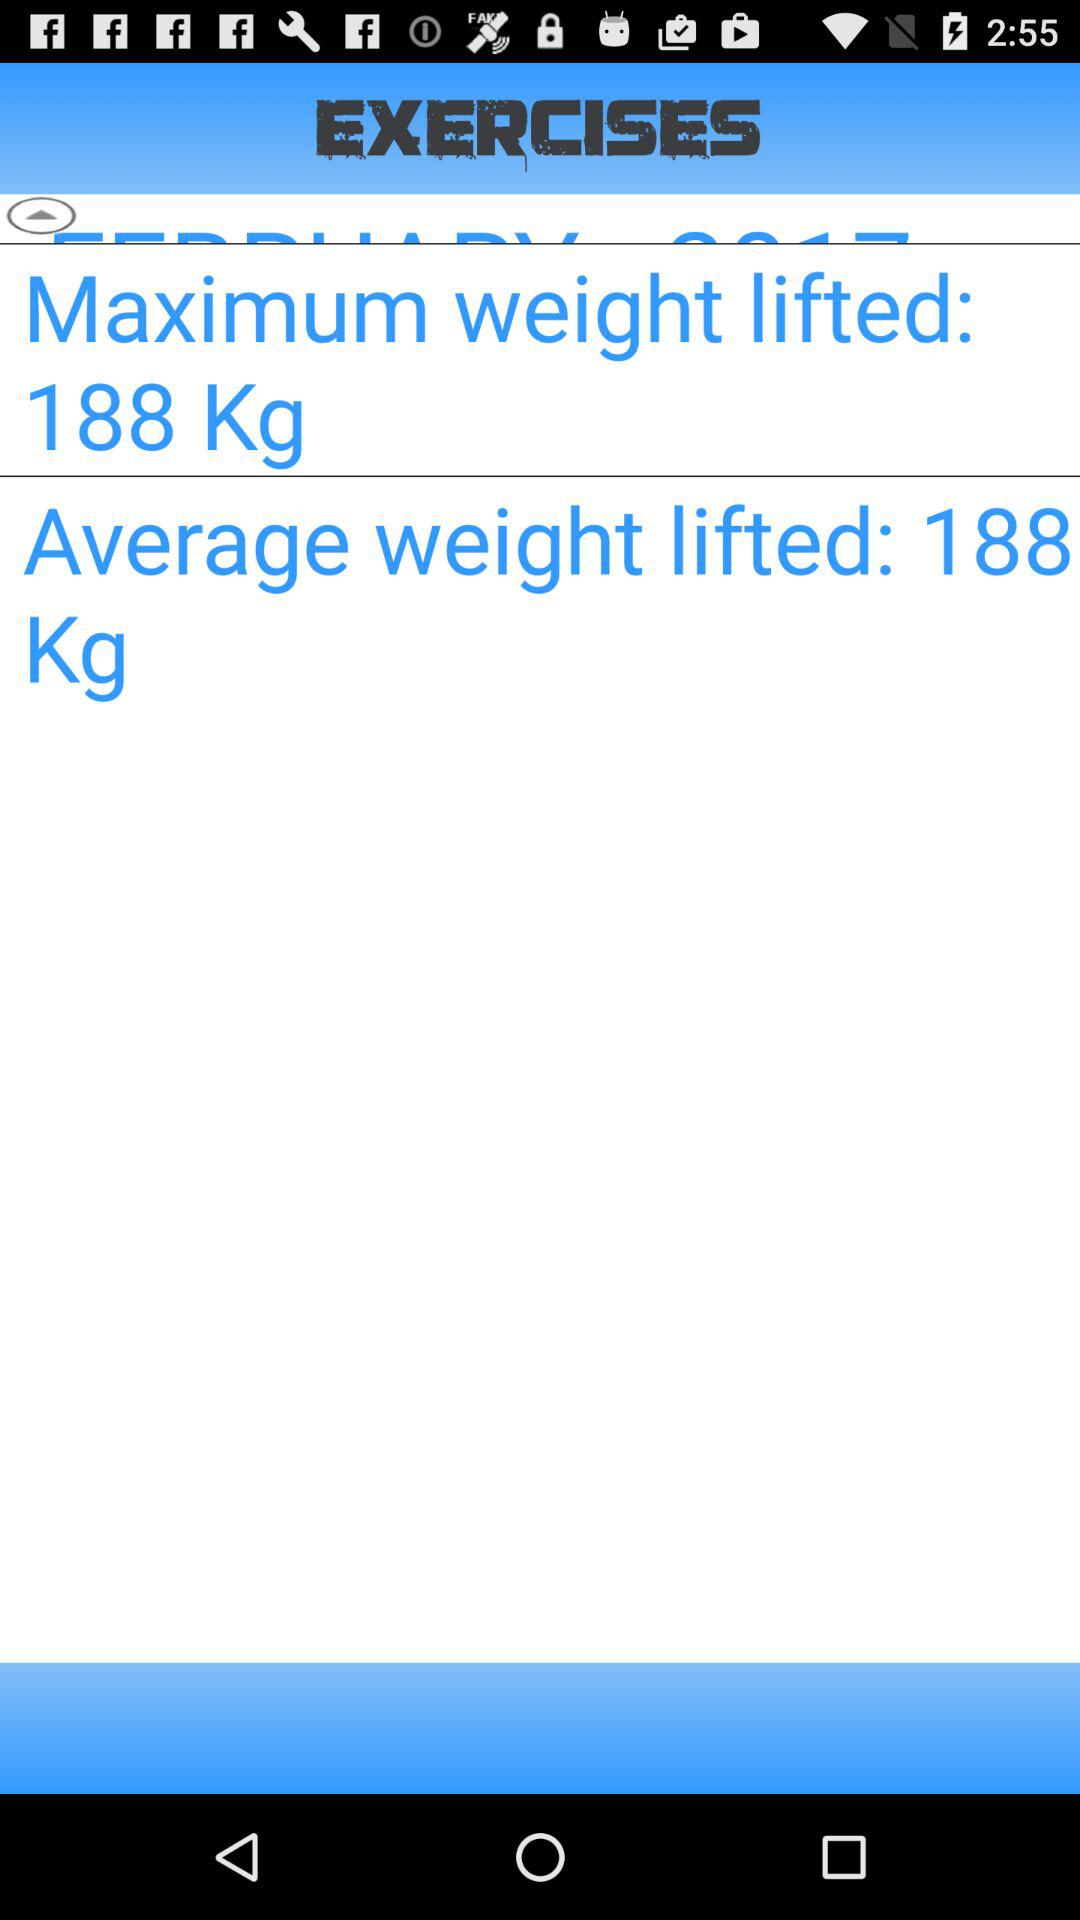What is the application name? The application name is "EXERCISES". 